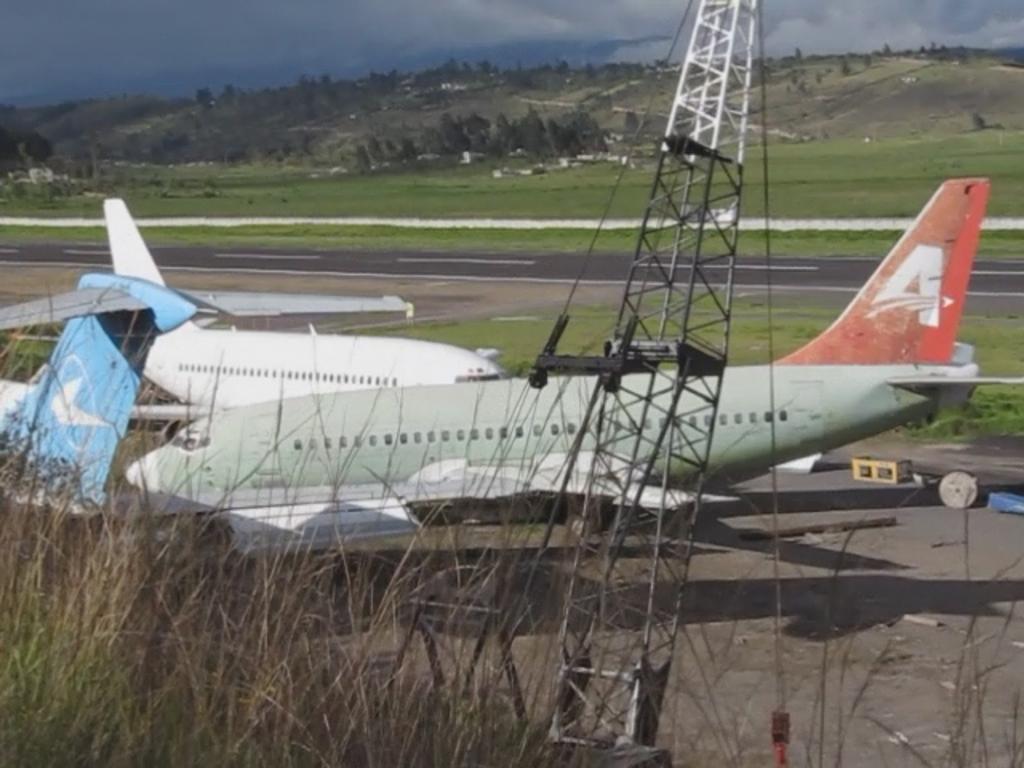What letter is printed on the rear of the plane in the red area?
Offer a terse response. A. 